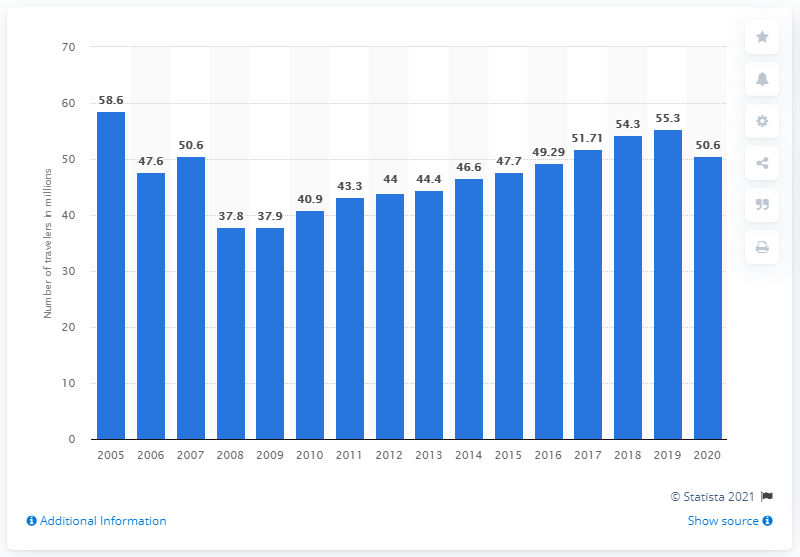Indicate a few pertinent items in this graphic. According to forecasts, it is expected that 50.6 people will travel over the Thanksgiving holiday period in 2020. 